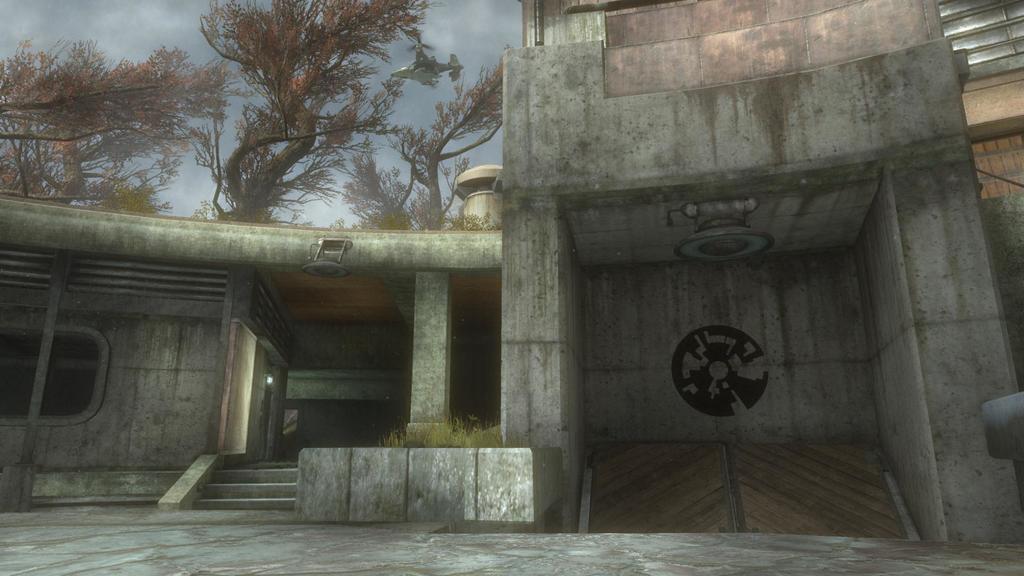Please provide a concise description of this image. In this picture we can see few buildings, plants and a light, in the background we can find few trees and a plane. 